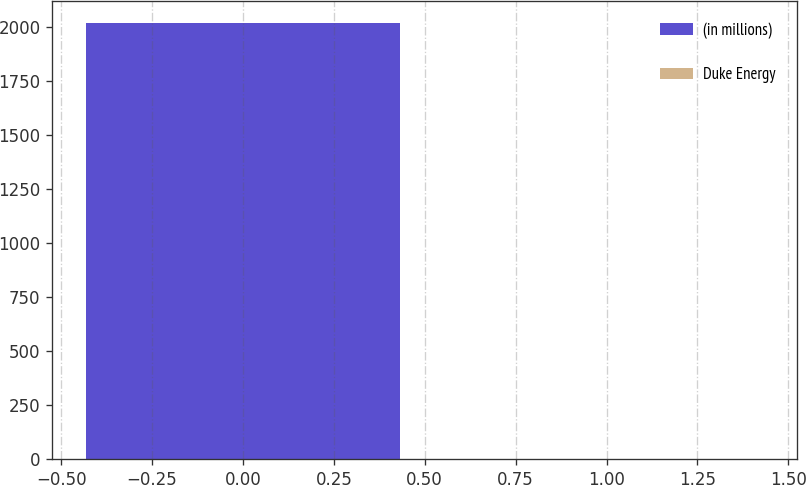Convert chart. <chart><loc_0><loc_0><loc_500><loc_500><bar_chart><fcel>(in millions)<fcel>Duke Energy<nl><fcel>2018<fcel>3<nl></chart> 